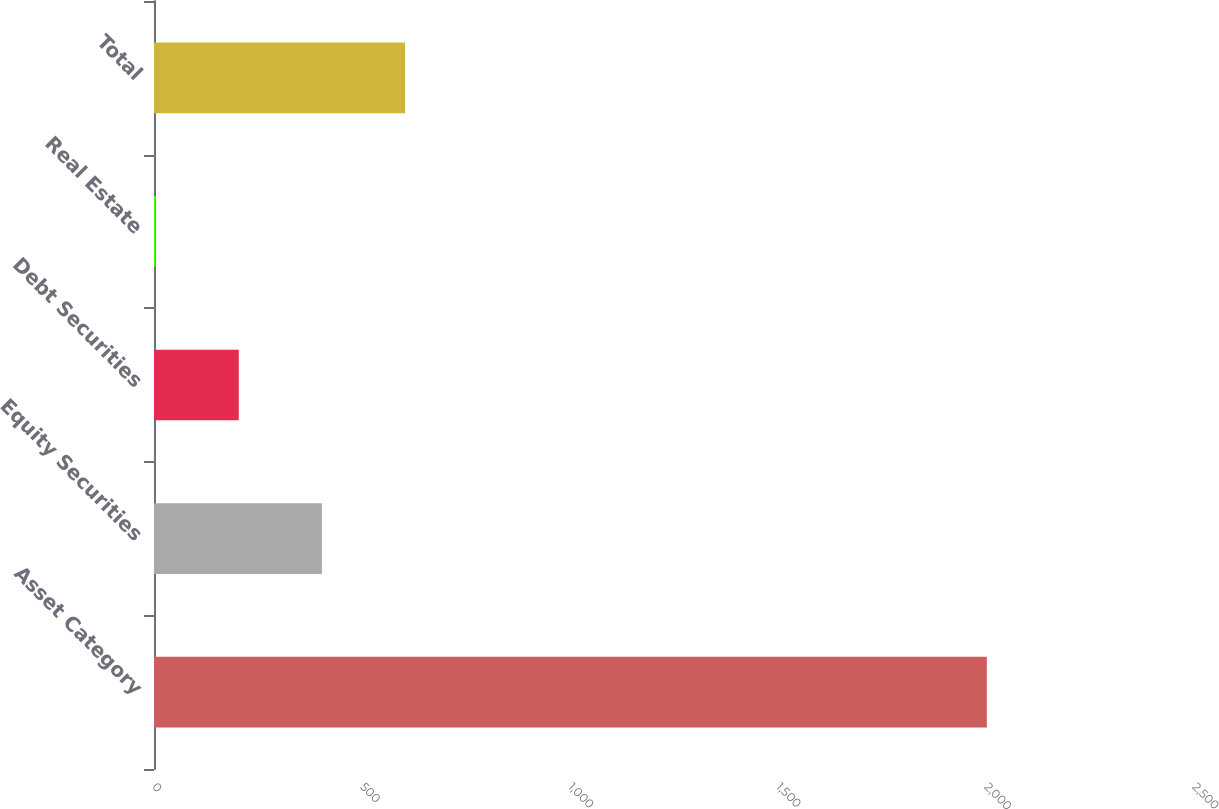<chart> <loc_0><loc_0><loc_500><loc_500><bar_chart><fcel>Asset Category<fcel>Equity Securities<fcel>Debt Securities<fcel>Real Estate<fcel>Total<nl><fcel>2002<fcel>403.6<fcel>203.8<fcel>4<fcel>603.4<nl></chart> 